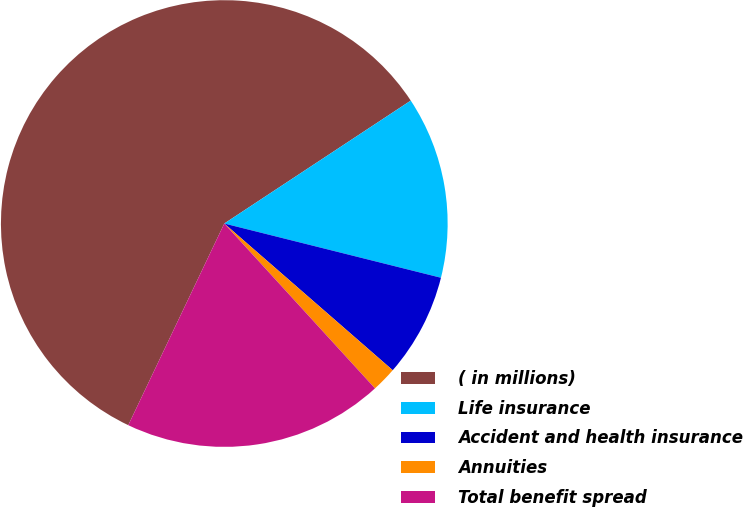Convert chart. <chart><loc_0><loc_0><loc_500><loc_500><pie_chart><fcel>( in millions)<fcel>Life insurance<fcel>Accident and health insurance<fcel>Annuities<fcel>Total benefit spread<nl><fcel>58.65%<fcel>13.18%<fcel>7.5%<fcel>1.81%<fcel>18.86%<nl></chart> 